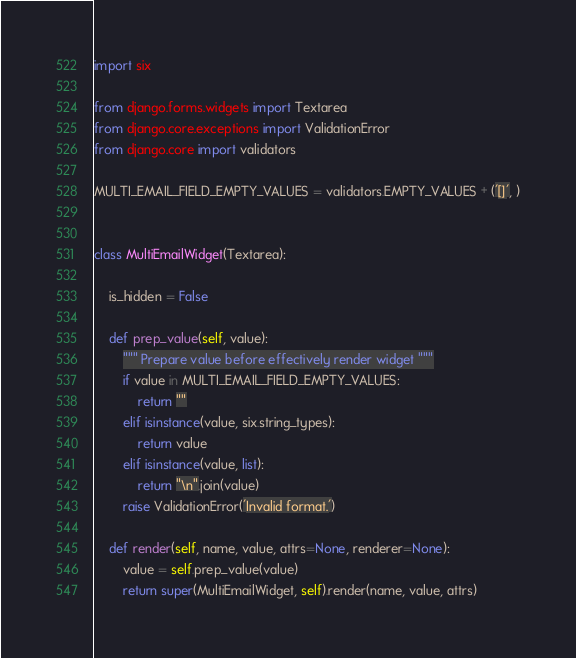Convert code to text. <code><loc_0><loc_0><loc_500><loc_500><_Python_>import six

from django.forms.widgets import Textarea
from django.core.exceptions import ValidationError
from django.core import validators

MULTI_EMAIL_FIELD_EMPTY_VALUES = validators.EMPTY_VALUES + ('[]', )


class MultiEmailWidget(Textarea):

    is_hidden = False

    def prep_value(self, value):
        """ Prepare value before effectively render widget """
        if value in MULTI_EMAIL_FIELD_EMPTY_VALUES:
            return ""
        elif isinstance(value, six.string_types):
            return value
        elif isinstance(value, list):
            return "\n".join(value)
        raise ValidationError('Invalid format.')

    def render(self, name, value, attrs=None, renderer=None):
        value = self.prep_value(value)
        return super(MultiEmailWidget, self).render(name, value, attrs)
</code> 